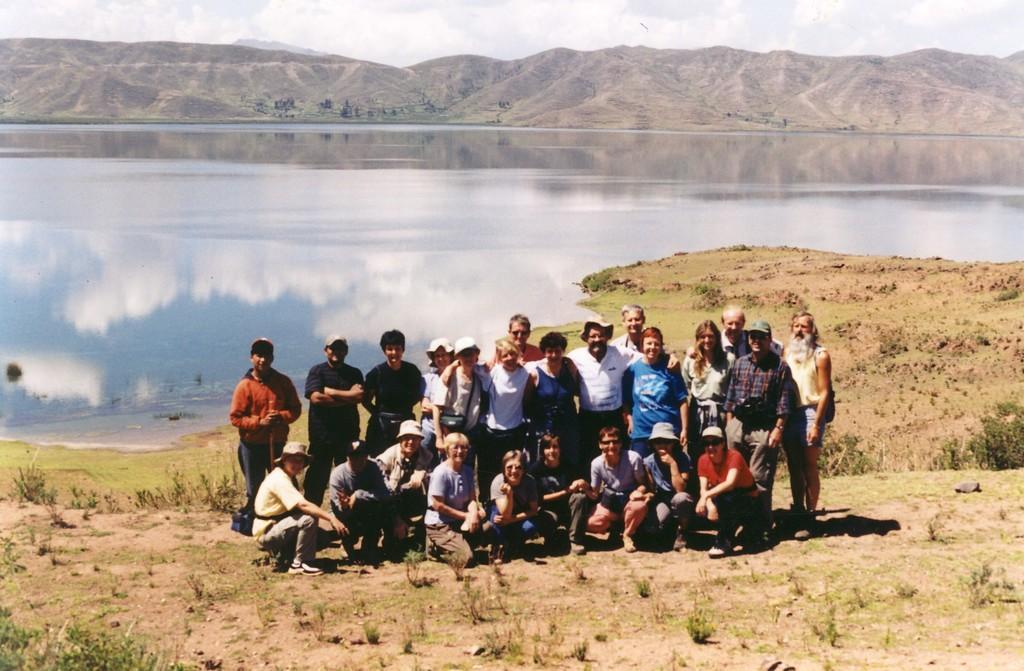In one or two sentences, can you explain what this image depicts? In the image on the ground there is grass and also there are few people. Behind them there is water. Behind the water there are hills. At the top of the image there is a sky with clouds. 